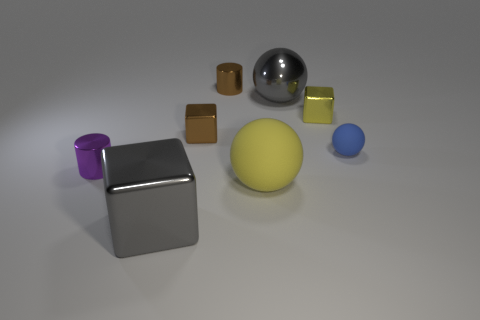There is a metallic thing that is the same color as the large metal block; what size is it?
Your answer should be compact. Large. Are the large sphere behind the tiny yellow block and the small sphere made of the same material?
Ensure brevity in your answer.  No. What number of other things are the same color as the large metallic ball?
Give a very brief answer. 1. How many other things are the same shape as the tiny purple thing?
Provide a short and direct response. 1. Do the large metal object that is behind the brown metal cube and the gray metal thing that is in front of the small purple object have the same shape?
Your answer should be very brief. No. Are there the same number of rubber objects in front of the blue object and yellow rubber things in front of the yellow block?
Ensure brevity in your answer.  Yes. The gray object to the right of the gray thing in front of the big ball that is behind the small purple cylinder is what shape?
Ensure brevity in your answer.  Sphere. Do the yellow object that is behind the yellow rubber sphere and the gray thing in front of the tiny yellow shiny object have the same material?
Make the answer very short. Yes. What shape is the rubber object to the right of the big yellow sphere?
Give a very brief answer. Sphere. Are there fewer large shiny objects than green objects?
Your answer should be very brief. No. 